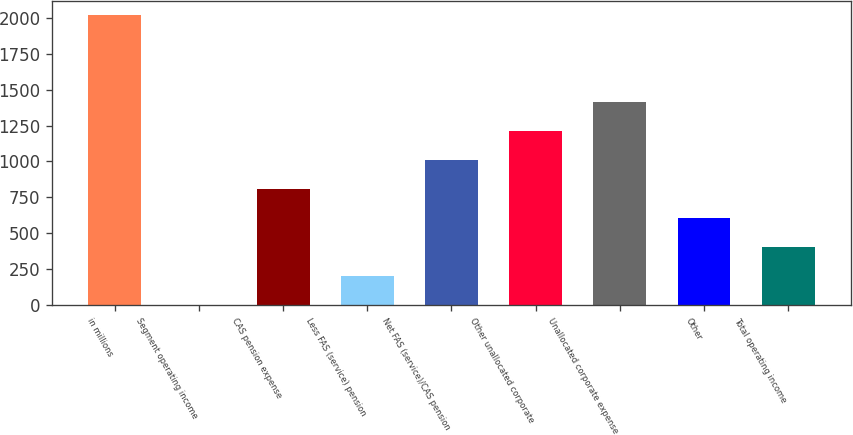Convert chart. <chart><loc_0><loc_0><loc_500><loc_500><bar_chart><fcel>in millions<fcel>Segment operating income<fcel>CAS pension expense<fcel>Less FAS (service) pension<fcel>Net FAS (service)/CAS pension<fcel>Other unallocated corporate<fcel>Unallocated corporate expense<fcel>Other<fcel>Total operating income<nl><fcel>2017<fcel>1<fcel>807.4<fcel>202.6<fcel>1009<fcel>1210.6<fcel>1412.2<fcel>605.8<fcel>404.2<nl></chart> 